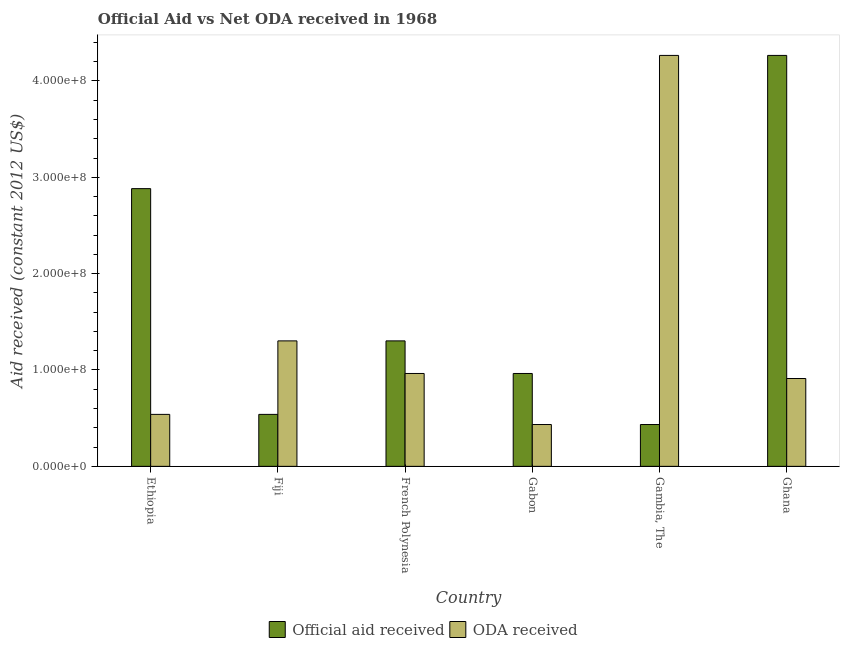How many different coloured bars are there?
Make the answer very short. 2. How many groups of bars are there?
Your answer should be compact. 6. Are the number of bars per tick equal to the number of legend labels?
Provide a succinct answer. Yes. How many bars are there on the 6th tick from the left?
Offer a terse response. 2. How many bars are there on the 4th tick from the right?
Provide a succinct answer. 2. What is the label of the 2nd group of bars from the left?
Ensure brevity in your answer.  Fiji. What is the oda received in Fiji?
Offer a very short reply. 1.30e+08. Across all countries, what is the maximum official aid received?
Your response must be concise. 4.26e+08. Across all countries, what is the minimum official aid received?
Provide a short and direct response. 4.34e+07. In which country was the oda received maximum?
Offer a terse response. Gambia, The. In which country was the official aid received minimum?
Your answer should be very brief. Gambia, The. What is the total oda received in the graph?
Your answer should be very brief. 8.42e+08. What is the difference between the official aid received in Gabon and that in Ghana?
Your response must be concise. -3.30e+08. What is the difference between the oda received in Fiji and the official aid received in Gabon?
Keep it short and to the point. 3.38e+07. What is the average oda received per country?
Provide a short and direct response. 1.40e+08. What is the difference between the oda received and official aid received in Gambia, The?
Make the answer very short. 3.83e+08. In how many countries, is the official aid received greater than 80000000 US$?
Offer a very short reply. 4. What is the ratio of the oda received in Gabon to that in Ghana?
Provide a succinct answer. 0.48. What is the difference between the highest and the second highest oda received?
Ensure brevity in your answer.  2.96e+08. What is the difference between the highest and the lowest official aid received?
Provide a succinct answer. 3.83e+08. What does the 2nd bar from the left in Ethiopia represents?
Your response must be concise. ODA received. What does the 1st bar from the right in Ghana represents?
Your answer should be compact. ODA received. How many bars are there?
Your response must be concise. 12. Are all the bars in the graph horizontal?
Ensure brevity in your answer.  No. How many countries are there in the graph?
Your answer should be very brief. 6. What is the difference between two consecutive major ticks on the Y-axis?
Offer a very short reply. 1.00e+08. Where does the legend appear in the graph?
Ensure brevity in your answer.  Bottom center. How are the legend labels stacked?
Your response must be concise. Horizontal. What is the title of the graph?
Provide a succinct answer. Official Aid vs Net ODA received in 1968 . Does "Males" appear as one of the legend labels in the graph?
Your answer should be very brief. No. What is the label or title of the Y-axis?
Offer a terse response. Aid received (constant 2012 US$). What is the Aid received (constant 2012 US$) in Official aid received in Ethiopia?
Provide a succinct answer. 2.88e+08. What is the Aid received (constant 2012 US$) in ODA received in Ethiopia?
Give a very brief answer. 5.39e+07. What is the Aid received (constant 2012 US$) in Official aid received in Fiji?
Your answer should be very brief. 5.39e+07. What is the Aid received (constant 2012 US$) of ODA received in Fiji?
Make the answer very short. 1.30e+08. What is the Aid received (constant 2012 US$) in Official aid received in French Polynesia?
Your answer should be compact. 1.30e+08. What is the Aid received (constant 2012 US$) of ODA received in French Polynesia?
Your response must be concise. 9.64e+07. What is the Aid received (constant 2012 US$) of Official aid received in Gabon?
Make the answer very short. 9.64e+07. What is the Aid received (constant 2012 US$) of ODA received in Gabon?
Your response must be concise. 4.34e+07. What is the Aid received (constant 2012 US$) in Official aid received in Gambia, The?
Give a very brief answer. 4.34e+07. What is the Aid received (constant 2012 US$) of ODA received in Gambia, The?
Provide a short and direct response. 4.26e+08. What is the Aid received (constant 2012 US$) of Official aid received in Ghana?
Provide a succinct answer. 4.26e+08. What is the Aid received (constant 2012 US$) in ODA received in Ghana?
Keep it short and to the point. 9.12e+07. Across all countries, what is the maximum Aid received (constant 2012 US$) of Official aid received?
Offer a very short reply. 4.26e+08. Across all countries, what is the maximum Aid received (constant 2012 US$) of ODA received?
Give a very brief answer. 4.26e+08. Across all countries, what is the minimum Aid received (constant 2012 US$) of Official aid received?
Your response must be concise. 4.34e+07. Across all countries, what is the minimum Aid received (constant 2012 US$) of ODA received?
Offer a very short reply. 4.34e+07. What is the total Aid received (constant 2012 US$) in Official aid received in the graph?
Provide a succinct answer. 1.04e+09. What is the total Aid received (constant 2012 US$) in ODA received in the graph?
Offer a very short reply. 8.42e+08. What is the difference between the Aid received (constant 2012 US$) of Official aid received in Ethiopia and that in Fiji?
Your answer should be compact. 2.34e+08. What is the difference between the Aid received (constant 2012 US$) of ODA received in Ethiopia and that in Fiji?
Make the answer very short. -7.63e+07. What is the difference between the Aid received (constant 2012 US$) in Official aid received in Ethiopia and that in French Polynesia?
Give a very brief answer. 1.58e+08. What is the difference between the Aid received (constant 2012 US$) of ODA received in Ethiopia and that in French Polynesia?
Provide a succinct answer. -4.24e+07. What is the difference between the Aid received (constant 2012 US$) of Official aid received in Ethiopia and that in Gabon?
Your response must be concise. 1.92e+08. What is the difference between the Aid received (constant 2012 US$) in ODA received in Ethiopia and that in Gabon?
Your answer should be compact. 1.05e+07. What is the difference between the Aid received (constant 2012 US$) of Official aid received in Ethiopia and that in Gambia, The?
Offer a very short reply. 2.45e+08. What is the difference between the Aid received (constant 2012 US$) of ODA received in Ethiopia and that in Gambia, The?
Provide a short and direct response. -3.73e+08. What is the difference between the Aid received (constant 2012 US$) in Official aid received in Ethiopia and that in Ghana?
Your answer should be very brief. -1.38e+08. What is the difference between the Aid received (constant 2012 US$) of ODA received in Ethiopia and that in Ghana?
Give a very brief answer. -3.72e+07. What is the difference between the Aid received (constant 2012 US$) in Official aid received in Fiji and that in French Polynesia?
Make the answer very short. -7.63e+07. What is the difference between the Aid received (constant 2012 US$) in ODA received in Fiji and that in French Polynesia?
Provide a short and direct response. 3.38e+07. What is the difference between the Aid received (constant 2012 US$) in Official aid received in Fiji and that in Gabon?
Offer a terse response. -4.24e+07. What is the difference between the Aid received (constant 2012 US$) in ODA received in Fiji and that in Gabon?
Your response must be concise. 8.68e+07. What is the difference between the Aid received (constant 2012 US$) in Official aid received in Fiji and that in Gambia, The?
Offer a very short reply. 1.05e+07. What is the difference between the Aid received (constant 2012 US$) in ODA received in Fiji and that in Gambia, The?
Give a very brief answer. -2.96e+08. What is the difference between the Aid received (constant 2012 US$) in Official aid received in Fiji and that in Ghana?
Your answer should be very brief. -3.73e+08. What is the difference between the Aid received (constant 2012 US$) in ODA received in Fiji and that in Ghana?
Provide a succinct answer. 3.90e+07. What is the difference between the Aid received (constant 2012 US$) of Official aid received in French Polynesia and that in Gabon?
Your response must be concise. 3.38e+07. What is the difference between the Aid received (constant 2012 US$) of ODA received in French Polynesia and that in Gabon?
Provide a succinct answer. 5.30e+07. What is the difference between the Aid received (constant 2012 US$) of Official aid received in French Polynesia and that in Gambia, The?
Ensure brevity in your answer.  8.68e+07. What is the difference between the Aid received (constant 2012 US$) of ODA received in French Polynesia and that in Gambia, The?
Keep it short and to the point. -3.30e+08. What is the difference between the Aid received (constant 2012 US$) of Official aid received in French Polynesia and that in Ghana?
Your answer should be very brief. -2.96e+08. What is the difference between the Aid received (constant 2012 US$) of ODA received in French Polynesia and that in Ghana?
Give a very brief answer. 5.21e+06. What is the difference between the Aid received (constant 2012 US$) in Official aid received in Gabon and that in Gambia, The?
Your response must be concise. 5.30e+07. What is the difference between the Aid received (constant 2012 US$) of ODA received in Gabon and that in Gambia, The?
Keep it short and to the point. -3.83e+08. What is the difference between the Aid received (constant 2012 US$) in Official aid received in Gabon and that in Ghana?
Provide a short and direct response. -3.30e+08. What is the difference between the Aid received (constant 2012 US$) of ODA received in Gabon and that in Ghana?
Make the answer very short. -4.78e+07. What is the difference between the Aid received (constant 2012 US$) of Official aid received in Gambia, The and that in Ghana?
Provide a short and direct response. -3.83e+08. What is the difference between the Aid received (constant 2012 US$) of ODA received in Gambia, The and that in Ghana?
Ensure brevity in your answer.  3.35e+08. What is the difference between the Aid received (constant 2012 US$) in Official aid received in Ethiopia and the Aid received (constant 2012 US$) in ODA received in Fiji?
Make the answer very short. 1.58e+08. What is the difference between the Aid received (constant 2012 US$) of Official aid received in Ethiopia and the Aid received (constant 2012 US$) of ODA received in French Polynesia?
Keep it short and to the point. 1.92e+08. What is the difference between the Aid received (constant 2012 US$) of Official aid received in Ethiopia and the Aid received (constant 2012 US$) of ODA received in Gabon?
Make the answer very short. 2.45e+08. What is the difference between the Aid received (constant 2012 US$) of Official aid received in Ethiopia and the Aid received (constant 2012 US$) of ODA received in Gambia, The?
Give a very brief answer. -1.38e+08. What is the difference between the Aid received (constant 2012 US$) in Official aid received in Ethiopia and the Aid received (constant 2012 US$) in ODA received in Ghana?
Give a very brief answer. 1.97e+08. What is the difference between the Aid received (constant 2012 US$) of Official aid received in Fiji and the Aid received (constant 2012 US$) of ODA received in French Polynesia?
Keep it short and to the point. -4.24e+07. What is the difference between the Aid received (constant 2012 US$) in Official aid received in Fiji and the Aid received (constant 2012 US$) in ODA received in Gabon?
Give a very brief answer. 1.05e+07. What is the difference between the Aid received (constant 2012 US$) in Official aid received in Fiji and the Aid received (constant 2012 US$) in ODA received in Gambia, The?
Your answer should be compact. -3.73e+08. What is the difference between the Aid received (constant 2012 US$) of Official aid received in Fiji and the Aid received (constant 2012 US$) of ODA received in Ghana?
Your response must be concise. -3.72e+07. What is the difference between the Aid received (constant 2012 US$) in Official aid received in French Polynesia and the Aid received (constant 2012 US$) in ODA received in Gabon?
Make the answer very short. 8.68e+07. What is the difference between the Aid received (constant 2012 US$) of Official aid received in French Polynesia and the Aid received (constant 2012 US$) of ODA received in Gambia, The?
Your answer should be compact. -2.96e+08. What is the difference between the Aid received (constant 2012 US$) in Official aid received in French Polynesia and the Aid received (constant 2012 US$) in ODA received in Ghana?
Offer a terse response. 3.90e+07. What is the difference between the Aid received (constant 2012 US$) in Official aid received in Gabon and the Aid received (constant 2012 US$) in ODA received in Gambia, The?
Your response must be concise. -3.30e+08. What is the difference between the Aid received (constant 2012 US$) of Official aid received in Gabon and the Aid received (constant 2012 US$) of ODA received in Ghana?
Provide a succinct answer. 5.21e+06. What is the difference between the Aid received (constant 2012 US$) in Official aid received in Gambia, The and the Aid received (constant 2012 US$) in ODA received in Ghana?
Provide a succinct answer. -4.78e+07. What is the average Aid received (constant 2012 US$) of Official aid received per country?
Your response must be concise. 1.73e+08. What is the average Aid received (constant 2012 US$) in ODA received per country?
Your response must be concise. 1.40e+08. What is the difference between the Aid received (constant 2012 US$) of Official aid received and Aid received (constant 2012 US$) of ODA received in Ethiopia?
Provide a short and direct response. 2.34e+08. What is the difference between the Aid received (constant 2012 US$) of Official aid received and Aid received (constant 2012 US$) of ODA received in Fiji?
Keep it short and to the point. -7.63e+07. What is the difference between the Aid received (constant 2012 US$) of Official aid received and Aid received (constant 2012 US$) of ODA received in French Polynesia?
Your answer should be very brief. 3.38e+07. What is the difference between the Aid received (constant 2012 US$) in Official aid received and Aid received (constant 2012 US$) in ODA received in Gabon?
Your answer should be compact. 5.30e+07. What is the difference between the Aid received (constant 2012 US$) of Official aid received and Aid received (constant 2012 US$) of ODA received in Gambia, The?
Your answer should be compact. -3.83e+08. What is the difference between the Aid received (constant 2012 US$) of Official aid received and Aid received (constant 2012 US$) of ODA received in Ghana?
Ensure brevity in your answer.  3.35e+08. What is the ratio of the Aid received (constant 2012 US$) of Official aid received in Ethiopia to that in Fiji?
Provide a succinct answer. 5.34. What is the ratio of the Aid received (constant 2012 US$) in ODA received in Ethiopia to that in Fiji?
Make the answer very short. 0.41. What is the ratio of the Aid received (constant 2012 US$) in Official aid received in Ethiopia to that in French Polynesia?
Keep it short and to the point. 2.21. What is the ratio of the Aid received (constant 2012 US$) in ODA received in Ethiopia to that in French Polynesia?
Offer a very short reply. 0.56. What is the ratio of the Aid received (constant 2012 US$) of Official aid received in Ethiopia to that in Gabon?
Give a very brief answer. 2.99. What is the ratio of the Aid received (constant 2012 US$) of ODA received in Ethiopia to that in Gabon?
Keep it short and to the point. 1.24. What is the ratio of the Aid received (constant 2012 US$) of Official aid received in Ethiopia to that in Gambia, The?
Make the answer very short. 6.64. What is the ratio of the Aid received (constant 2012 US$) of ODA received in Ethiopia to that in Gambia, The?
Your response must be concise. 0.13. What is the ratio of the Aid received (constant 2012 US$) of Official aid received in Ethiopia to that in Ghana?
Make the answer very short. 0.68. What is the ratio of the Aid received (constant 2012 US$) in ODA received in Ethiopia to that in Ghana?
Keep it short and to the point. 0.59. What is the ratio of the Aid received (constant 2012 US$) of Official aid received in Fiji to that in French Polynesia?
Ensure brevity in your answer.  0.41. What is the ratio of the Aid received (constant 2012 US$) in ODA received in Fiji to that in French Polynesia?
Ensure brevity in your answer.  1.35. What is the ratio of the Aid received (constant 2012 US$) in Official aid received in Fiji to that in Gabon?
Offer a very short reply. 0.56. What is the ratio of the Aid received (constant 2012 US$) in ODA received in Fiji to that in Gabon?
Offer a terse response. 3. What is the ratio of the Aid received (constant 2012 US$) in Official aid received in Fiji to that in Gambia, The?
Offer a very short reply. 1.24. What is the ratio of the Aid received (constant 2012 US$) of ODA received in Fiji to that in Gambia, The?
Provide a succinct answer. 0.31. What is the ratio of the Aid received (constant 2012 US$) in Official aid received in Fiji to that in Ghana?
Provide a short and direct response. 0.13. What is the ratio of the Aid received (constant 2012 US$) of ODA received in Fiji to that in Ghana?
Keep it short and to the point. 1.43. What is the ratio of the Aid received (constant 2012 US$) of Official aid received in French Polynesia to that in Gabon?
Your response must be concise. 1.35. What is the ratio of the Aid received (constant 2012 US$) in ODA received in French Polynesia to that in Gabon?
Make the answer very short. 2.22. What is the ratio of the Aid received (constant 2012 US$) in Official aid received in French Polynesia to that in Gambia, The?
Keep it short and to the point. 3. What is the ratio of the Aid received (constant 2012 US$) in ODA received in French Polynesia to that in Gambia, The?
Keep it short and to the point. 0.23. What is the ratio of the Aid received (constant 2012 US$) in Official aid received in French Polynesia to that in Ghana?
Your answer should be compact. 0.31. What is the ratio of the Aid received (constant 2012 US$) in ODA received in French Polynesia to that in Ghana?
Offer a terse response. 1.06. What is the ratio of the Aid received (constant 2012 US$) in Official aid received in Gabon to that in Gambia, The?
Offer a terse response. 2.22. What is the ratio of the Aid received (constant 2012 US$) of ODA received in Gabon to that in Gambia, The?
Provide a succinct answer. 0.1. What is the ratio of the Aid received (constant 2012 US$) in Official aid received in Gabon to that in Ghana?
Provide a succinct answer. 0.23. What is the ratio of the Aid received (constant 2012 US$) of ODA received in Gabon to that in Ghana?
Your response must be concise. 0.48. What is the ratio of the Aid received (constant 2012 US$) of Official aid received in Gambia, The to that in Ghana?
Give a very brief answer. 0.1. What is the ratio of the Aid received (constant 2012 US$) in ODA received in Gambia, The to that in Ghana?
Provide a succinct answer. 4.68. What is the difference between the highest and the second highest Aid received (constant 2012 US$) of Official aid received?
Provide a succinct answer. 1.38e+08. What is the difference between the highest and the second highest Aid received (constant 2012 US$) of ODA received?
Offer a terse response. 2.96e+08. What is the difference between the highest and the lowest Aid received (constant 2012 US$) of Official aid received?
Provide a short and direct response. 3.83e+08. What is the difference between the highest and the lowest Aid received (constant 2012 US$) of ODA received?
Your response must be concise. 3.83e+08. 